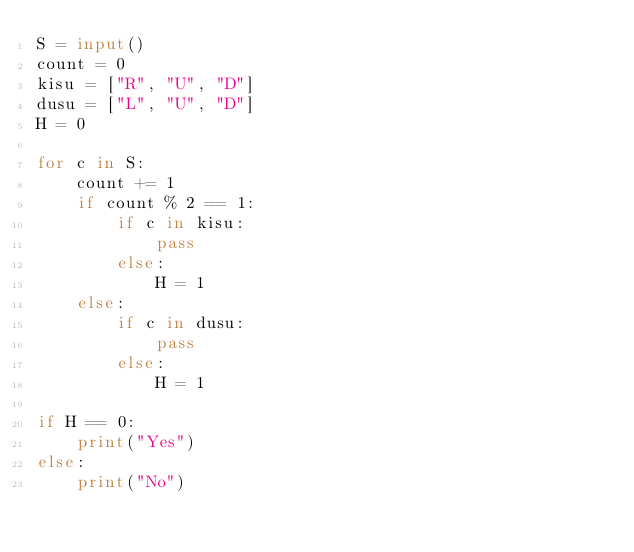Convert code to text. <code><loc_0><loc_0><loc_500><loc_500><_Python_>S = input()
count = 0
kisu = ["R", "U", "D"]
dusu = ["L", "U", "D"]
H = 0

for c in S:
    count += 1
    if count % 2 == 1:
        if c in kisu:
            pass
        else:
            H = 1
    else:
        if c in dusu:
            pass
        else:
            H = 1

if H == 0:
    print("Yes")
else:
    print("No")
    </code> 